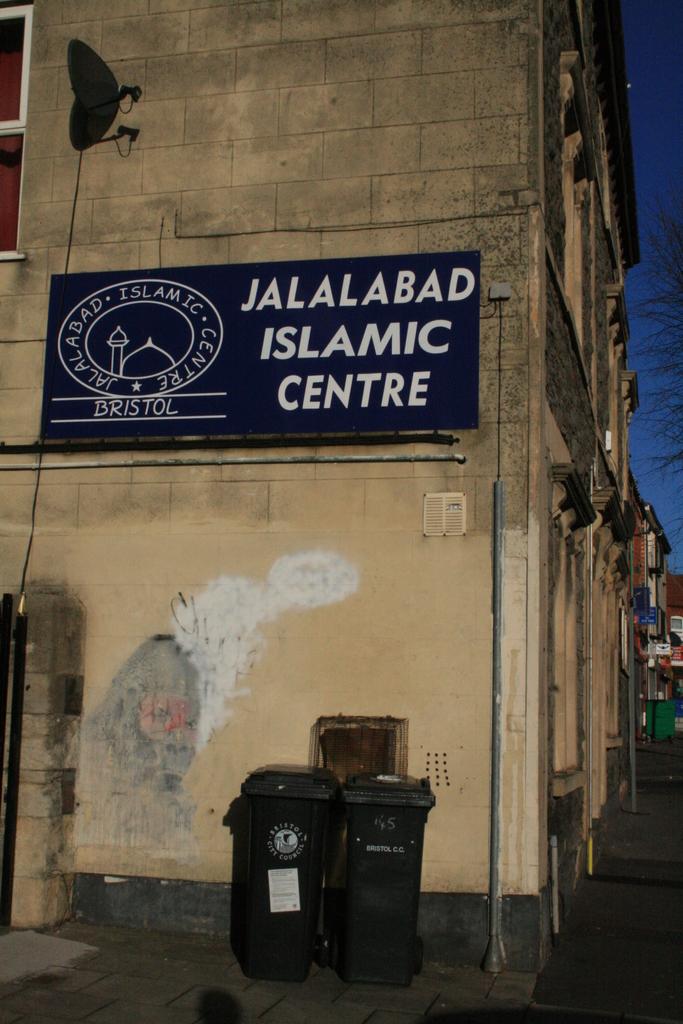What branch of the jalalabad islamic center is this?
Ensure brevity in your answer.  Bristol. What is the name of this islamic centre?
Offer a terse response. Jalalabad. 